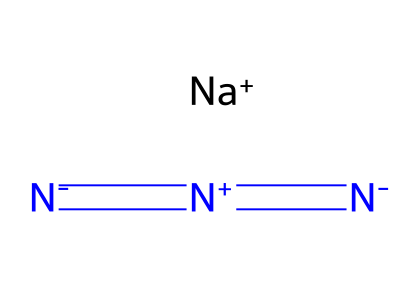How many nitrogen atoms are present in sodium azide? From the SMILES representation, there are three nitrogen atoms in the sequence between the equal signs and dashes. The structure consists of a sodium ion and a linear arrangement of three nitrogen atoms.
Answer: three What is the charge of the sodium ion in sodium azide? The sodium ion is represented as [Na+] in the SMILES, indicating that it carries a positive charge.
Answer: positive How many total atoms are in sodium azide? The chemical contains one sodium atom and three nitrogen atoms, giving a total of four atoms.
Answer: four What type of bonding is present between the nitrogen atoms in sodium azide? The structure shows equal signs and a dash between nitrogen atoms, indicating that they are connected by double bonds and a single bond, respectively. Therefore, there are both double and single bonds present.
Answer: double and single bonds What is the oxidation state of nitrogen in sodium azide? The nitrogen atoms in azides generally exhibit an oxidation state of -1 for two of the nitrogen atoms and +1 for the nitrogen bonded to sodium. Thus, the overall contribution reflects mixed oxidation states (-1, -1, +1).
Answer: mixed What characteristic of azides makes sodium azide useful in airbag systems? Azides release nitrogen gas rapidly upon decomposition, which is crucial for quickly inflating airbags. This rapid gas release and the formation of a non-toxic gas makes it suitable.
Answer: rapid gas release How does the molecular structure of sodium azide relate to its function in airbags? The linear arrangement of nitrogen in sodium azide helps produce a large volume of nitrogen gas when it decomposes, quickly filling the airbag. The structure’s stability under normal conditions also contributes to its utility.
Answer: large gas volume 